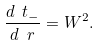<formula> <loc_0><loc_0><loc_500><loc_500>\frac { d \ t _ { - } } { d \ r } = W ^ { 2 } .</formula> 